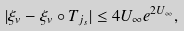Convert formula to latex. <formula><loc_0><loc_0><loc_500><loc_500>| \xi _ { v } - \xi _ { v } \circ T _ { j _ { s } } | \leq 4 U _ { \infty } e ^ { 2 U _ { \infty } } ,</formula> 